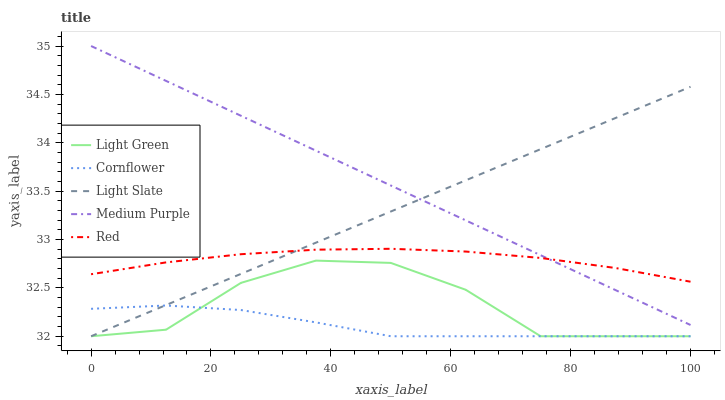Does Medium Purple have the minimum area under the curve?
Answer yes or no. No. Does Cornflower have the maximum area under the curve?
Answer yes or no. No. Is Cornflower the smoothest?
Answer yes or no. No. Is Cornflower the roughest?
Answer yes or no. No. Does Medium Purple have the lowest value?
Answer yes or no. No. Does Cornflower have the highest value?
Answer yes or no. No. Is Cornflower less than Red?
Answer yes or no. Yes. Is Red greater than Cornflower?
Answer yes or no. Yes. Does Cornflower intersect Red?
Answer yes or no. No. 